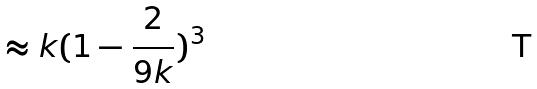Convert formula to latex. <formula><loc_0><loc_0><loc_500><loc_500>\approx k ( 1 - \frac { 2 } { 9 k } ) ^ { 3 }</formula> 